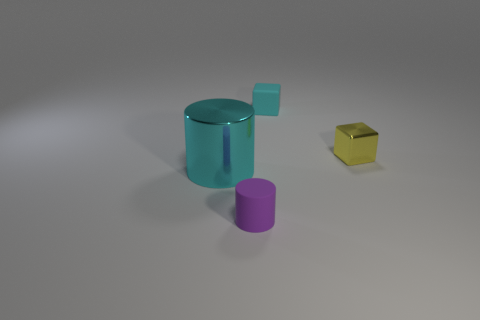Does the yellow object have the same material as the purple cylinder?
Offer a very short reply. No. What number of other things are the same material as the cyan cube?
Provide a short and direct response. 1. Are there any yellow shiny cubes to the right of the metal thing that is on the right side of the cyan object behind the small metallic block?
Provide a succinct answer. No. There is a shiny object to the right of the cyan shiny cylinder; is its shape the same as the tiny cyan thing?
Your answer should be very brief. Yes. Are there fewer small rubber objects that are to the left of the matte cylinder than big cyan objects that are to the left of the tiny yellow metal cube?
Ensure brevity in your answer.  Yes. What is the material of the purple object?
Offer a very short reply. Rubber. Does the big thing have the same color as the small matte thing behind the tiny yellow thing?
Offer a terse response. Yes. There is a tiny yellow shiny object; how many large things are behind it?
Ensure brevity in your answer.  0. Are there fewer big cyan things in front of the small cyan rubber thing than small blocks?
Your answer should be compact. Yes. The tiny matte block has what color?
Your answer should be very brief. Cyan. 